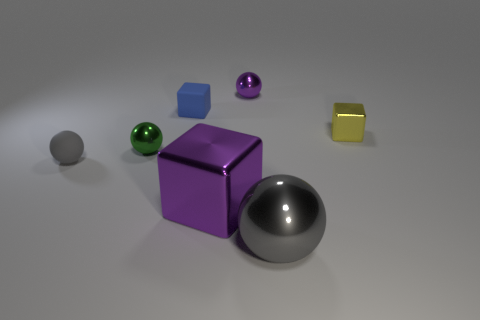What size is the purple thing behind the object that is to the right of the gray object right of the tiny blue matte block?
Provide a succinct answer. Small. The large purple shiny thing is what shape?
Keep it short and to the point. Cube. What is the size of the metal object that is the same color as the large block?
Offer a terse response. Small. There is a tiny metal ball that is to the left of the purple metal sphere; how many big balls are to the right of it?
Your answer should be compact. 1. What number of other objects are the same material as the big gray object?
Provide a succinct answer. 4. Do the gray thing in front of the small gray sphere and the small block on the right side of the tiny matte block have the same material?
Your answer should be compact. Yes. Is the small gray object made of the same material as the tiny ball that is behind the small rubber cube?
Make the answer very short. No. What is the color of the large metal object that is in front of the purple object that is in front of the tiny shiny ball to the left of the rubber cube?
Give a very brief answer. Gray. There is a purple shiny thing that is the same size as the yellow metallic thing; what shape is it?
Provide a succinct answer. Sphere. Is the size of the gray ball right of the small gray rubber object the same as the purple metallic object in front of the tiny blue object?
Provide a short and direct response. Yes. 